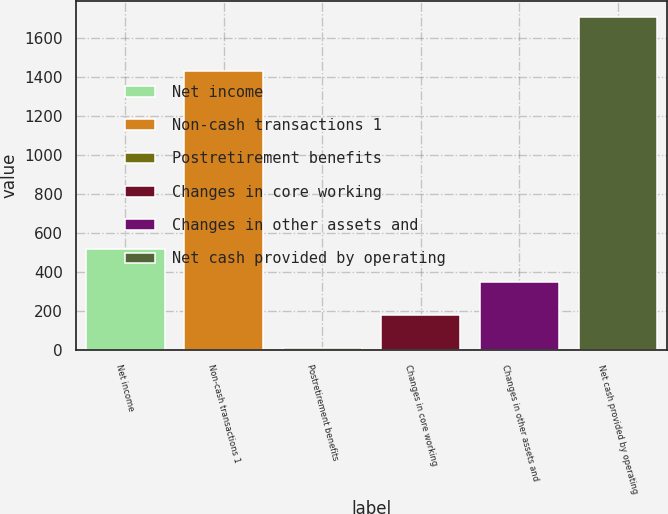<chart> <loc_0><loc_0><loc_500><loc_500><bar_chart><fcel>Net income<fcel>Non-cash transactions 1<fcel>Postretirement benefits<fcel>Changes in core working<fcel>Changes in other assets and<fcel>Net cash provided by operating<nl><fcel>519.9<fcel>1429<fcel>12<fcel>181.3<fcel>350.6<fcel>1705<nl></chart> 